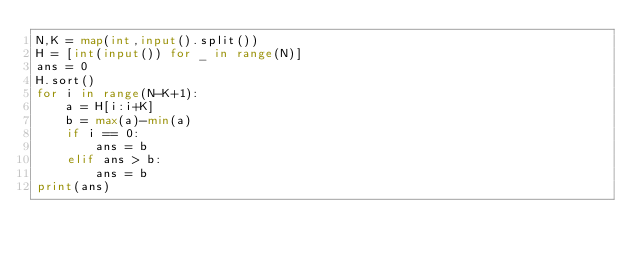Convert code to text. <code><loc_0><loc_0><loc_500><loc_500><_Python_>N,K = map(int,input().split())
H = [int(input()) for _ in range(N)]
ans = 0
H.sort()
for i in range(N-K+1):
    a = H[i:i+K]
    b = max(a)-min(a)
    if i == 0:
        ans = b
    elif ans > b:
        ans = b
print(ans)</code> 